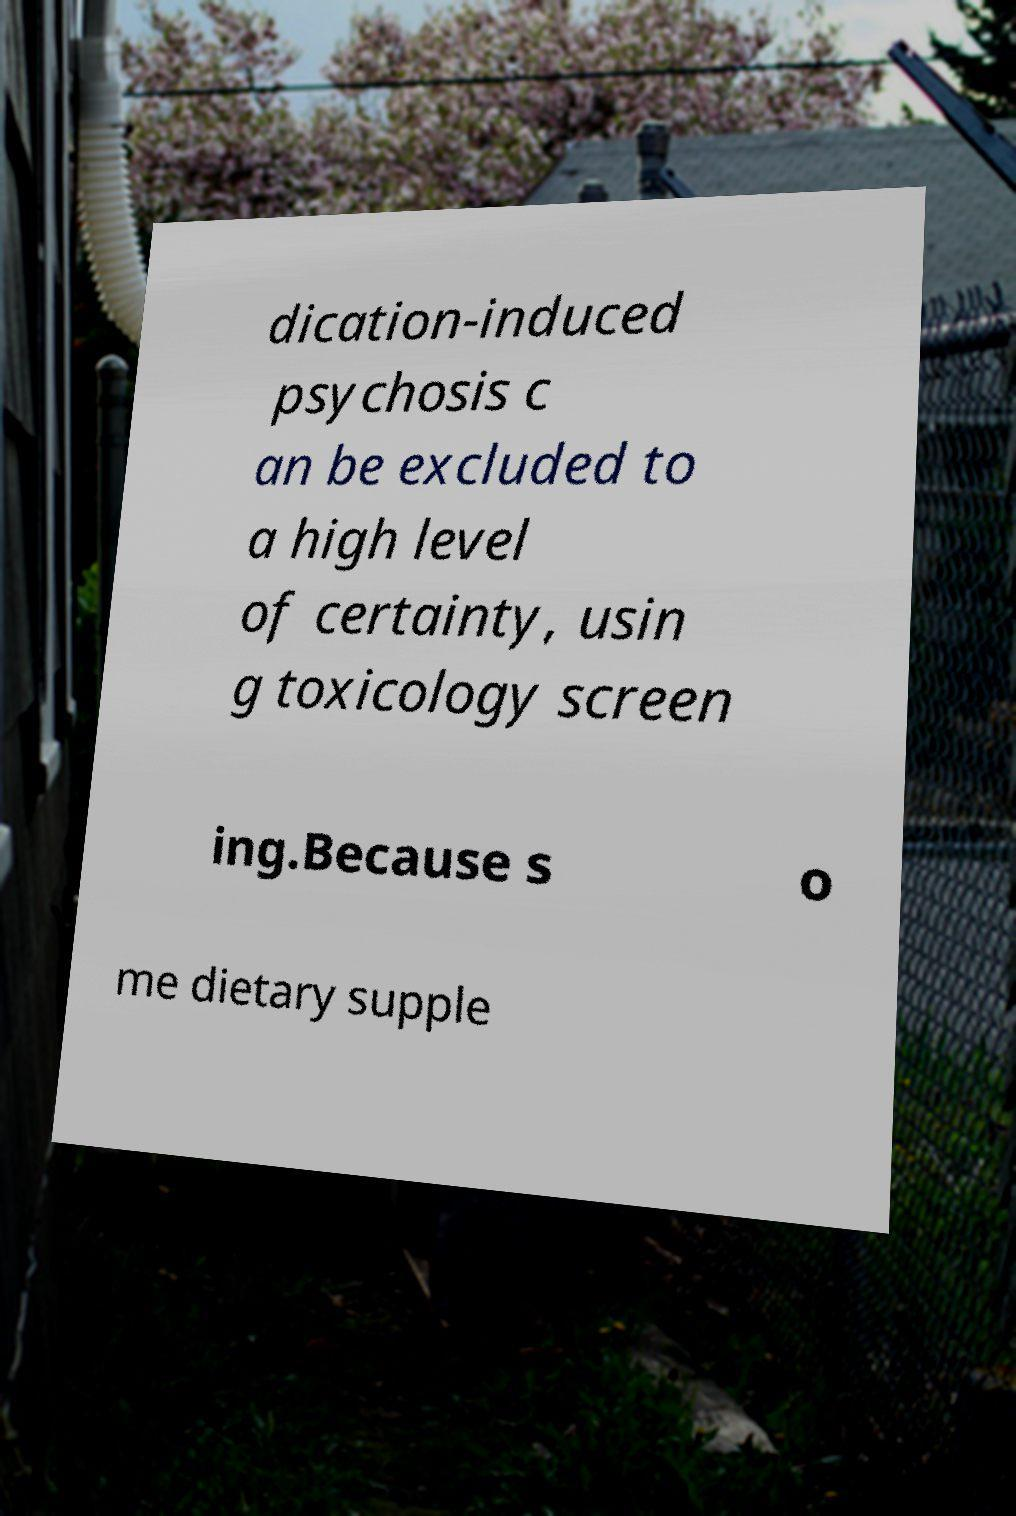For documentation purposes, I need the text within this image transcribed. Could you provide that? dication-induced psychosis c an be excluded to a high level of certainty, usin g toxicology screen ing.Because s o me dietary supple 